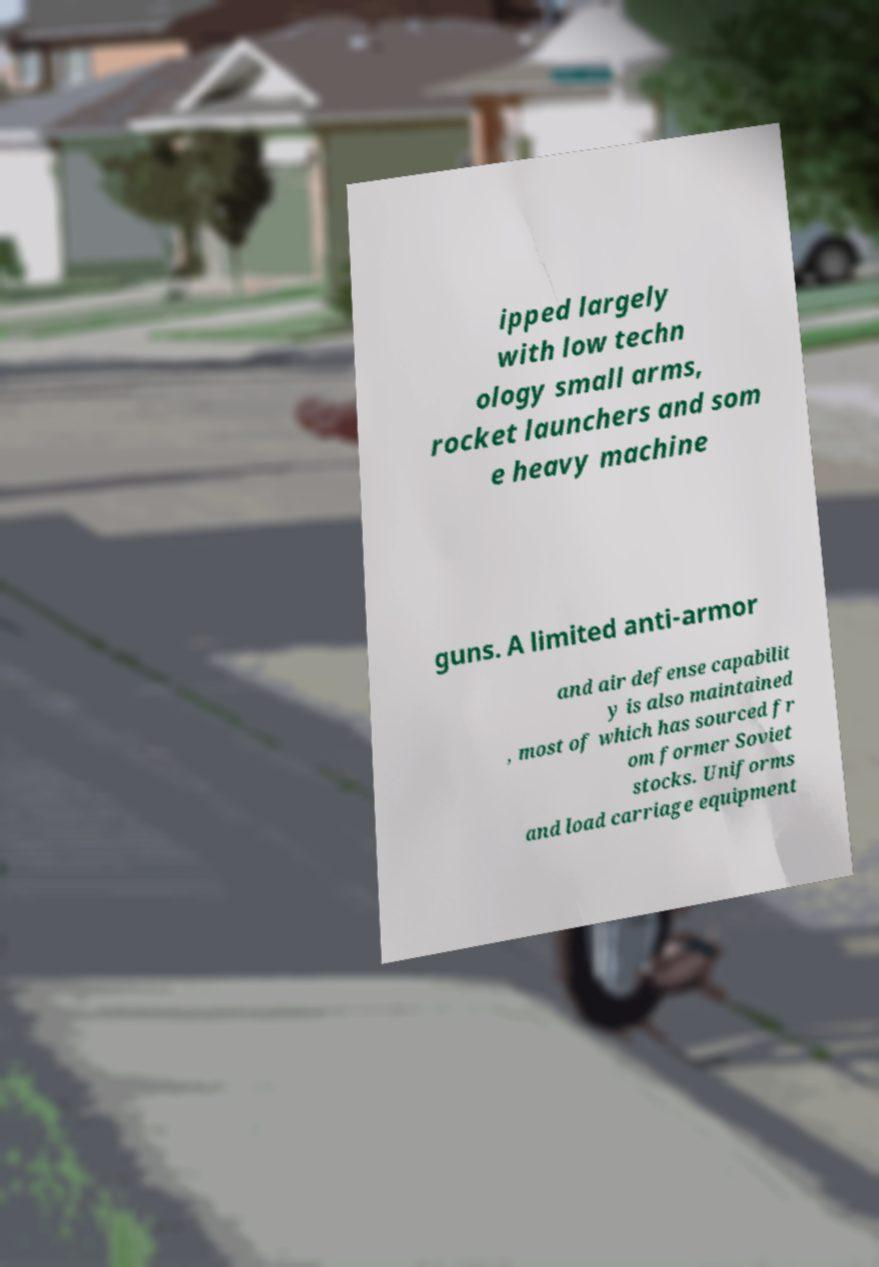Can you accurately transcribe the text from the provided image for me? ipped largely with low techn ology small arms, rocket launchers and som e heavy machine guns. A limited anti-armor and air defense capabilit y is also maintained , most of which has sourced fr om former Soviet stocks. Uniforms and load carriage equipment 